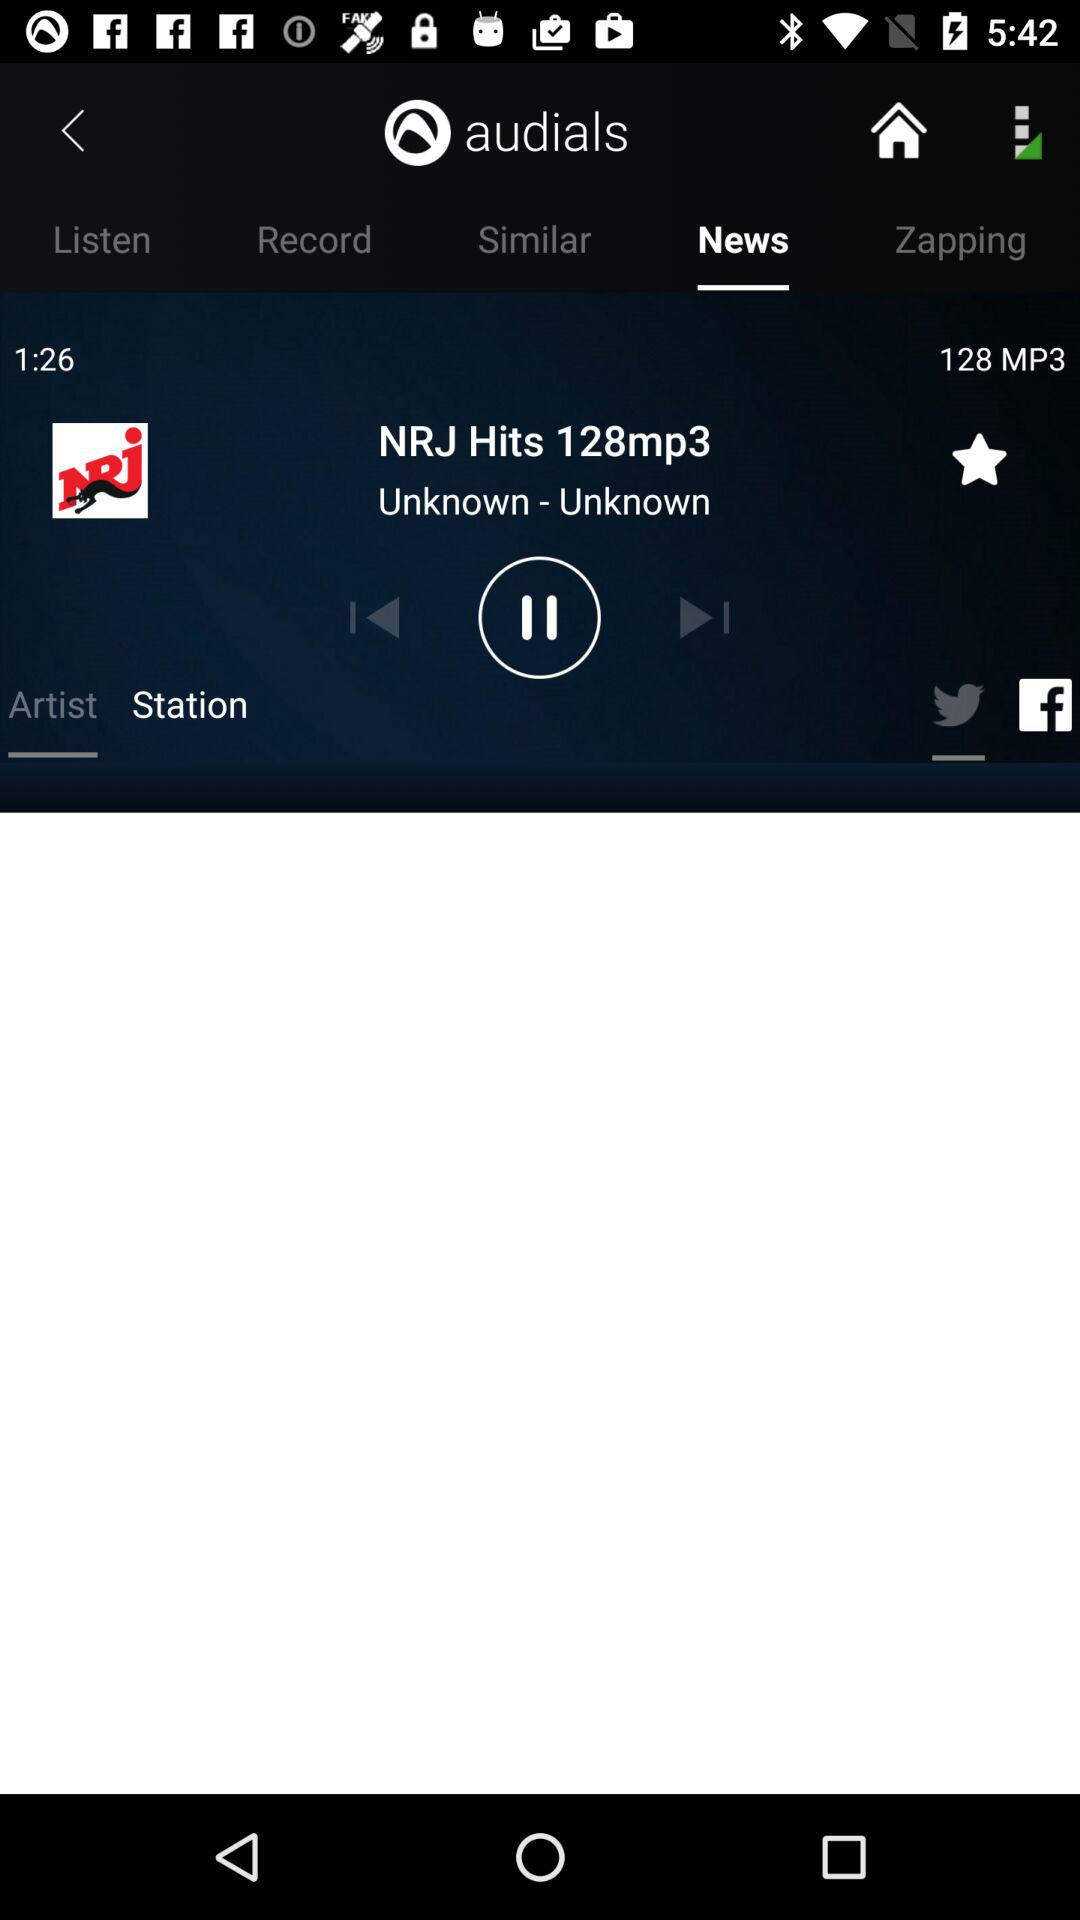What is the application name? The application name is "audials". 